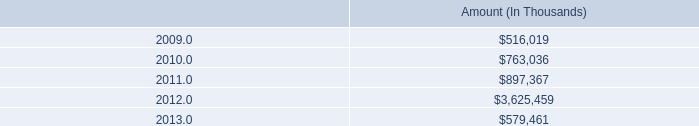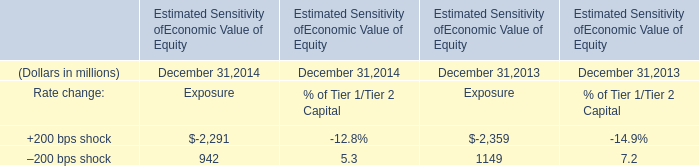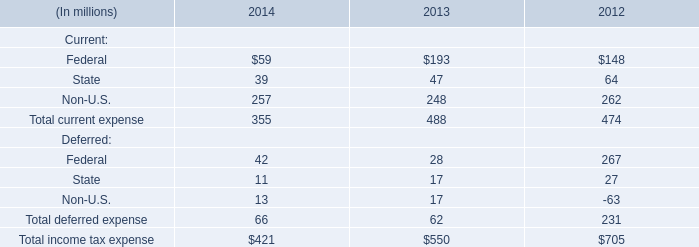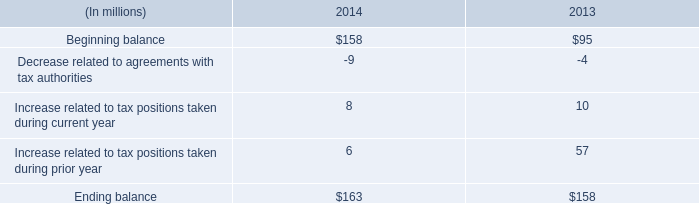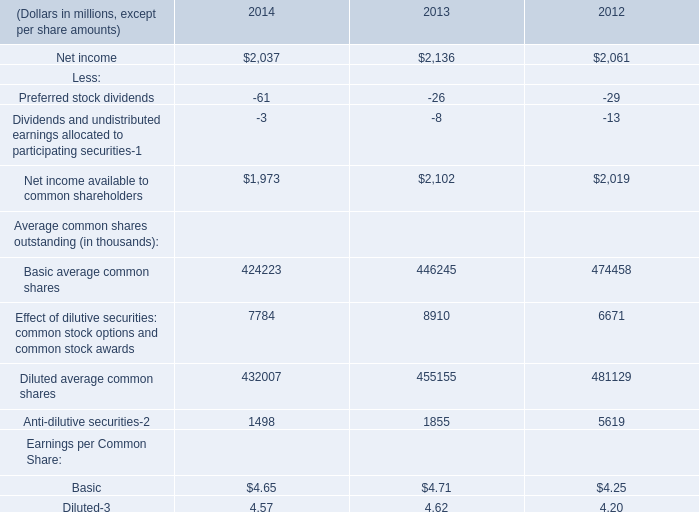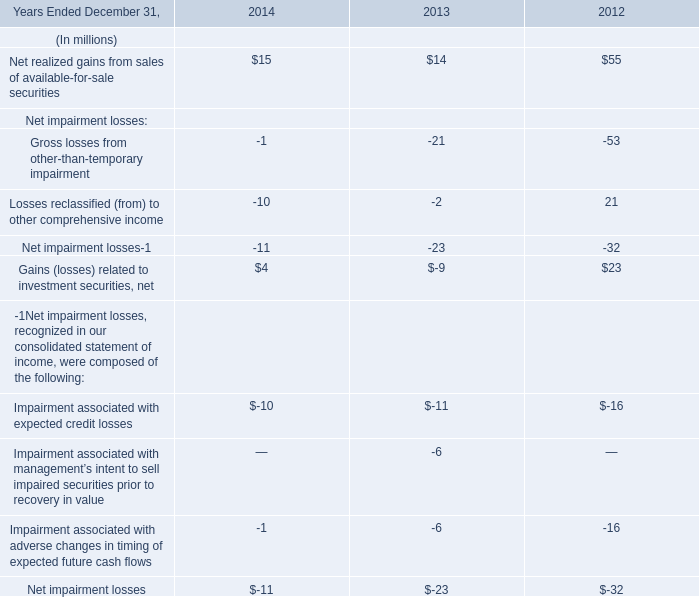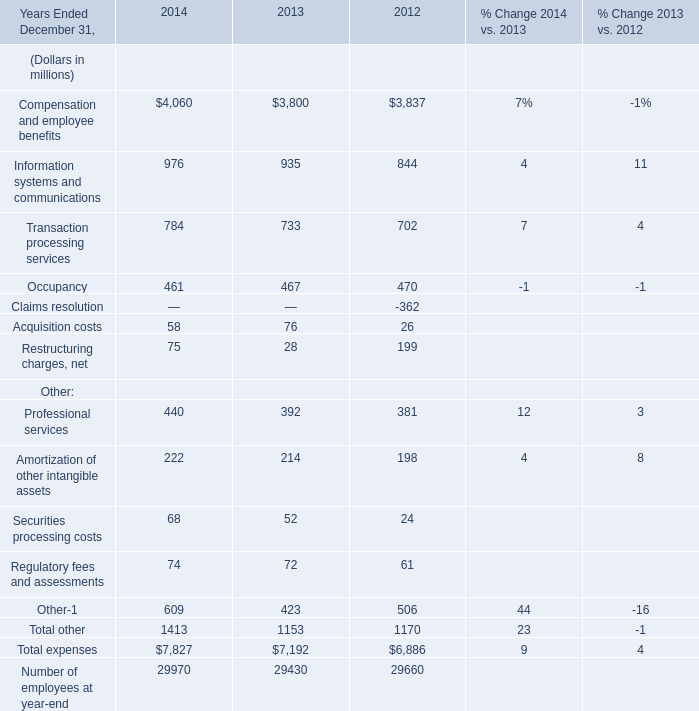What is the ratio of Professional services to the total expenses in 2013? 
Computations: (392 / 7192)
Answer: 0.05451. 